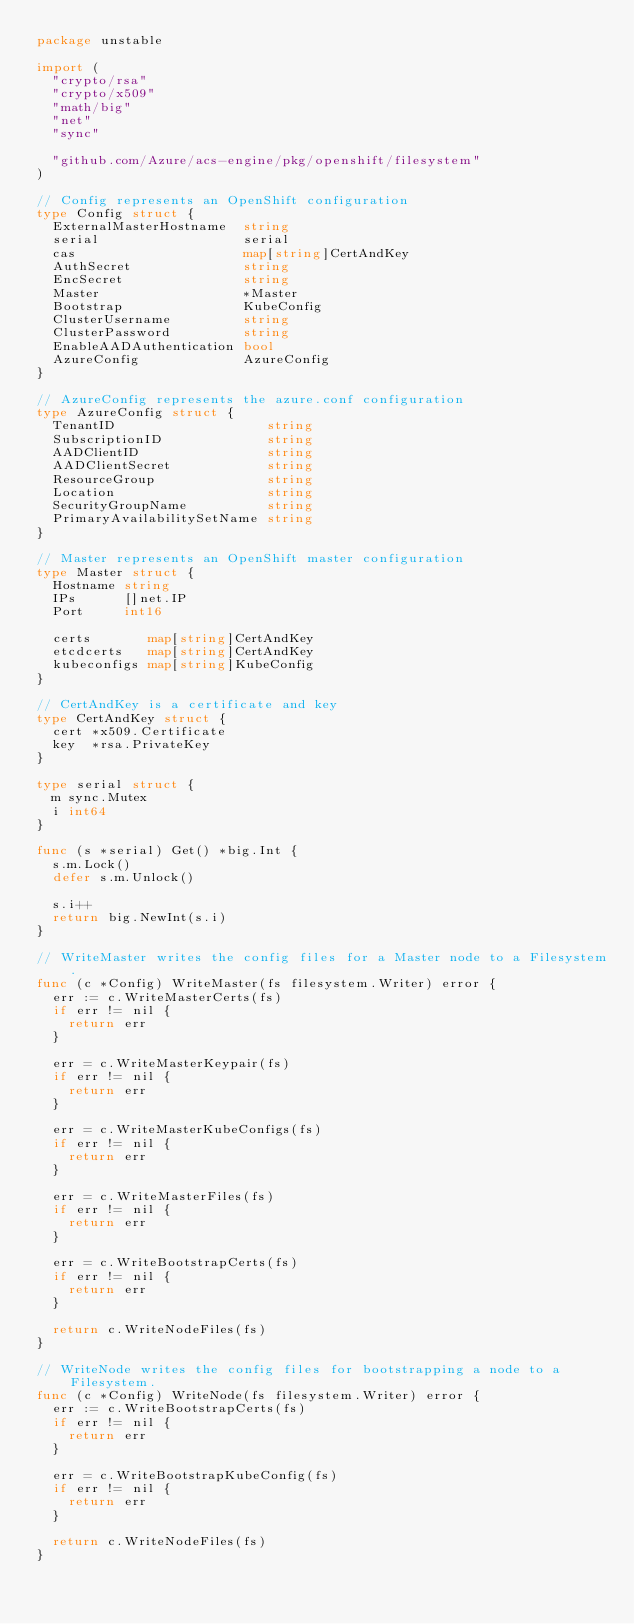Convert code to text. <code><loc_0><loc_0><loc_500><loc_500><_Go_>package unstable

import (
	"crypto/rsa"
	"crypto/x509"
	"math/big"
	"net"
	"sync"

	"github.com/Azure/acs-engine/pkg/openshift/filesystem"
)

// Config represents an OpenShift configuration
type Config struct {
	ExternalMasterHostname  string
	serial                  serial
	cas                     map[string]CertAndKey
	AuthSecret              string
	EncSecret               string
	Master                  *Master
	Bootstrap               KubeConfig
	ClusterUsername         string
	ClusterPassword         string
	EnableAADAuthentication bool
	AzureConfig             AzureConfig
}

// AzureConfig represents the azure.conf configuration
type AzureConfig struct {
	TenantID                   string
	SubscriptionID             string
	AADClientID                string
	AADClientSecret            string
	ResourceGroup              string
	Location                   string
	SecurityGroupName          string
	PrimaryAvailabilitySetName string
}

// Master represents an OpenShift master configuration
type Master struct {
	Hostname string
	IPs      []net.IP
	Port     int16

	certs       map[string]CertAndKey
	etcdcerts   map[string]CertAndKey
	kubeconfigs map[string]KubeConfig
}

// CertAndKey is a certificate and key
type CertAndKey struct {
	cert *x509.Certificate
	key  *rsa.PrivateKey
}

type serial struct {
	m sync.Mutex
	i int64
}

func (s *serial) Get() *big.Int {
	s.m.Lock()
	defer s.m.Unlock()

	s.i++
	return big.NewInt(s.i)
}

// WriteMaster writes the config files for a Master node to a Filesystem.
func (c *Config) WriteMaster(fs filesystem.Writer) error {
	err := c.WriteMasterCerts(fs)
	if err != nil {
		return err
	}

	err = c.WriteMasterKeypair(fs)
	if err != nil {
		return err
	}

	err = c.WriteMasterKubeConfigs(fs)
	if err != nil {
		return err
	}

	err = c.WriteMasterFiles(fs)
	if err != nil {
		return err
	}

	err = c.WriteBootstrapCerts(fs)
	if err != nil {
		return err
	}

	return c.WriteNodeFiles(fs)
}

// WriteNode writes the config files for bootstrapping a node to a Filesystem.
func (c *Config) WriteNode(fs filesystem.Writer) error {
	err := c.WriteBootstrapCerts(fs)
	if err != nil {
		return err
	}

	err = c.WriteBootstrapKubeConfig(fs)
	if err != nil {
		return err
	}

	return c.WriteNodeFiles(fs)
}
</code> 